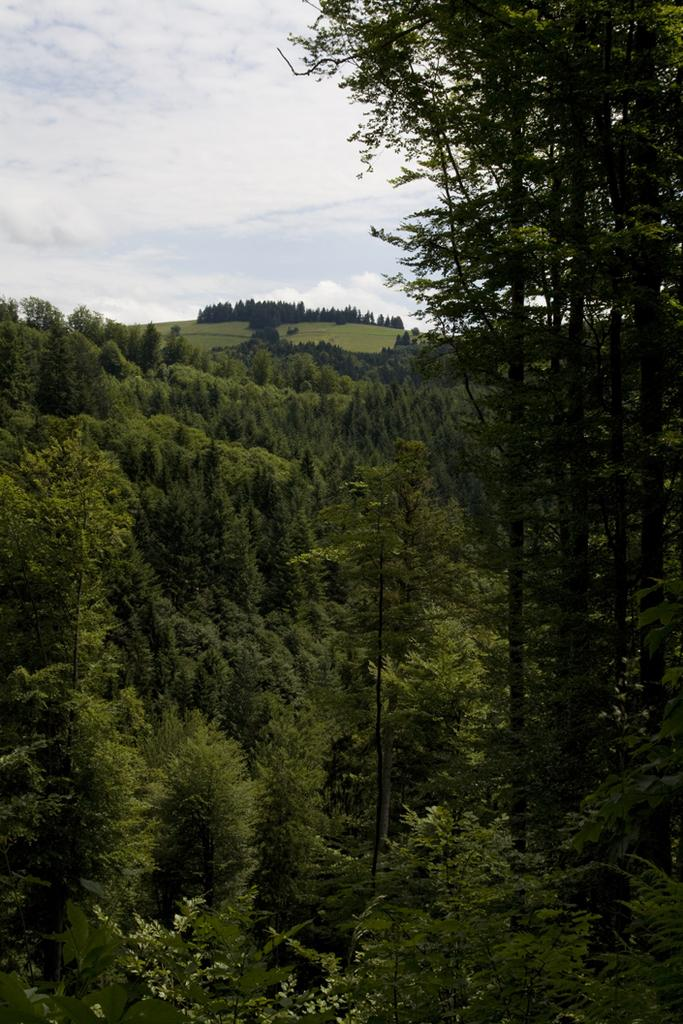What type of vegetation can be seen in the image? There are trees, plants, and grass in the image. Can you describe the ground in the image? The ground in the image is covered with grass. What is visible in the sky in the image? The sky is cloudy in the image. What type of art can be seen hanging from the trees in the image? There is no art hanging from the trees in the image; only trees, plants, grass, and a cloudy sky are present. 